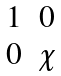<formula> <loc_0><loc_0><loc_500><loc_500>\begin{matrix} 1 & 0 \\ 0 & \chi \end{matrix}</formula> 